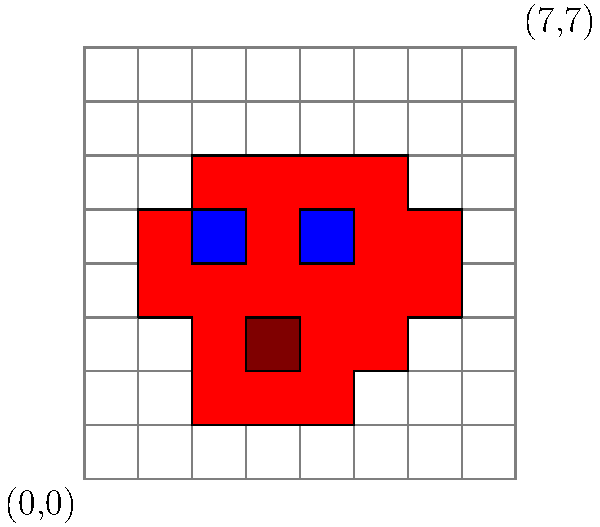In creating a pixelated Mario sprite, you're working with an 8x8 grid. The sprite's cap is represented by the red area. How many grid squares does Mario's cap occupy in this representation? To determine the number of grid squares occupied by Mario's cap, we need to follow these steps:

1. Identify the red area in the sprite, which represents Mario's cap.
2. Count the individual grid squares that are filled with red.
3. Be careful to include partially filled squares as well.

Let's count the red squares row by row:
- Row 1: 4 squares (from column 2 to 5)
- Row 2: 5 squares (from column 2 to 6)
- Row 3: 6 squares (from column 2 to 7)
- Row 4: 5 squares (from column 2 to 6)
- Row 5: 6 squares (from column 1 to 6)

Adding these up: 4 + 5 + 6 + 5 + 6 = 26

Therefore, Mario's cap occupies 26 grid squares in this 8x8 pixelated representation.
Answer: 26 squares 